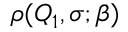Convert formula to latex. <formula><loc_0><loc_0><loc_500><loc_500>\rho ( Q _ { 1 } , \sigma ; \beta )</formula> 